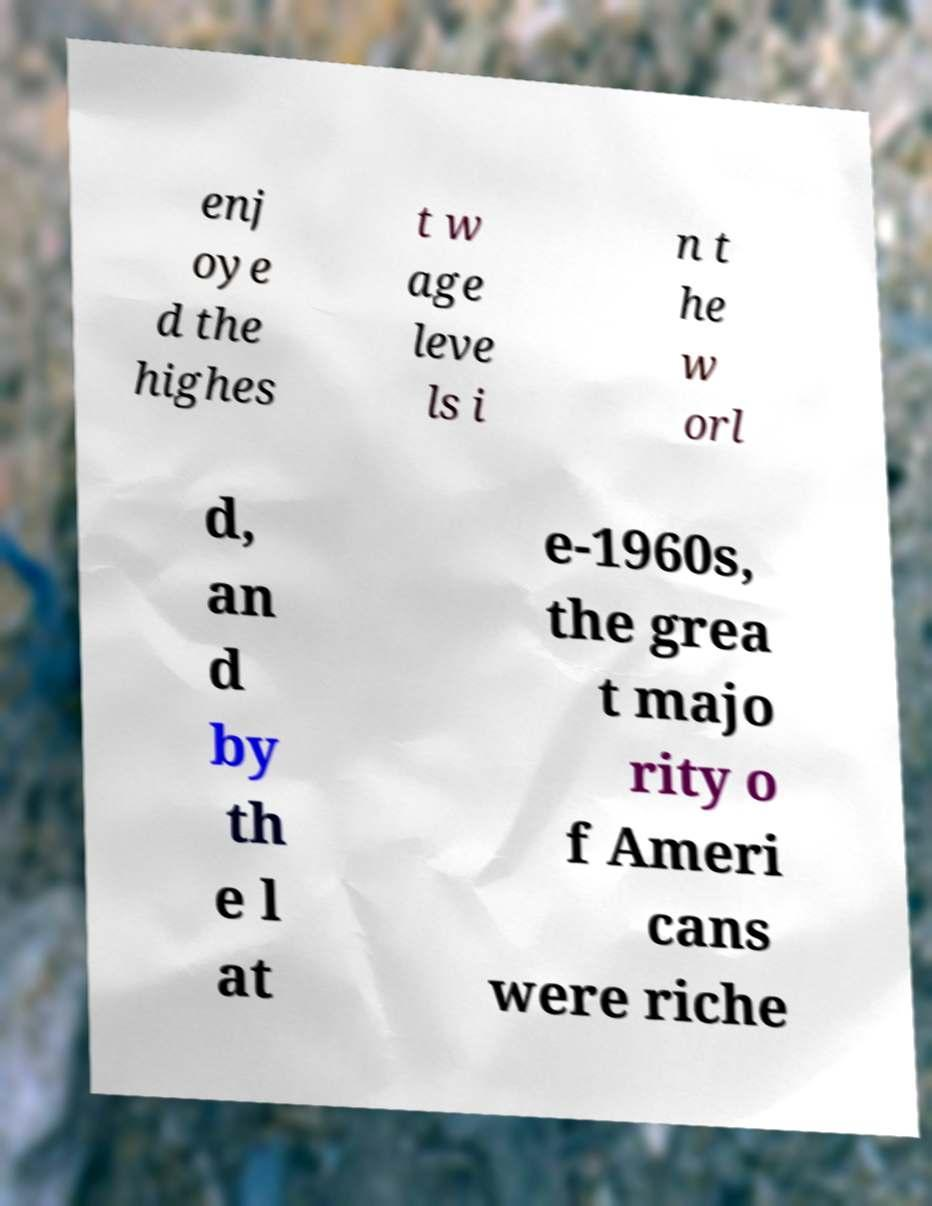What messages or text are displayed in this image? I need them in a readable, typed format. enj oye d the highes t w age leve ls i n t he w orl d, an d by th e l at e-1960s, the grea t majo rity o f Ameri cans were riche 